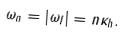Convert formula to latex. <formula><loc_0><loc_0><loc_500><loc_500>\omega _ { n } = \left | { \omega _ { I } } \right | = n \kappa _ { h } .</formula> 